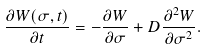<formula> <loc_0><loc_0><loc_500><loc_500>\frac { \partial W ( \sigma , t ) } { \partial t } = - \frac { \partial W } { \partial \sigma } + D \frac { \partial ^ { 2 } W } { \partial \sigma ^ { 2 } } .</formula> 